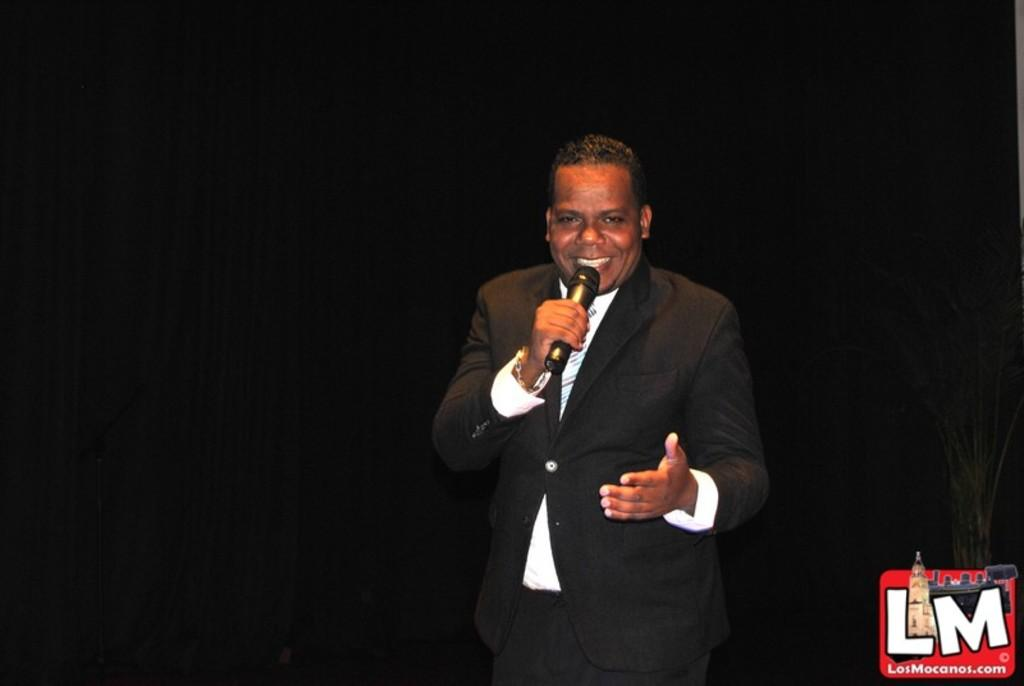What is the main subject of the image? The main subject of the image is a man. What is the man doing in the image? The man is standing and talking on a microphone. What is the man wearing in the image? The man is wearing a black suit. What expression does the man have in the image? The man is smiling in the image. What type of cracker is the man holding in the image? There is no cracker present in the image. What detail can be seen on the man's shoes in the image? The provided facts do not mention the man's shoes, so we cannot determine any details about them. 